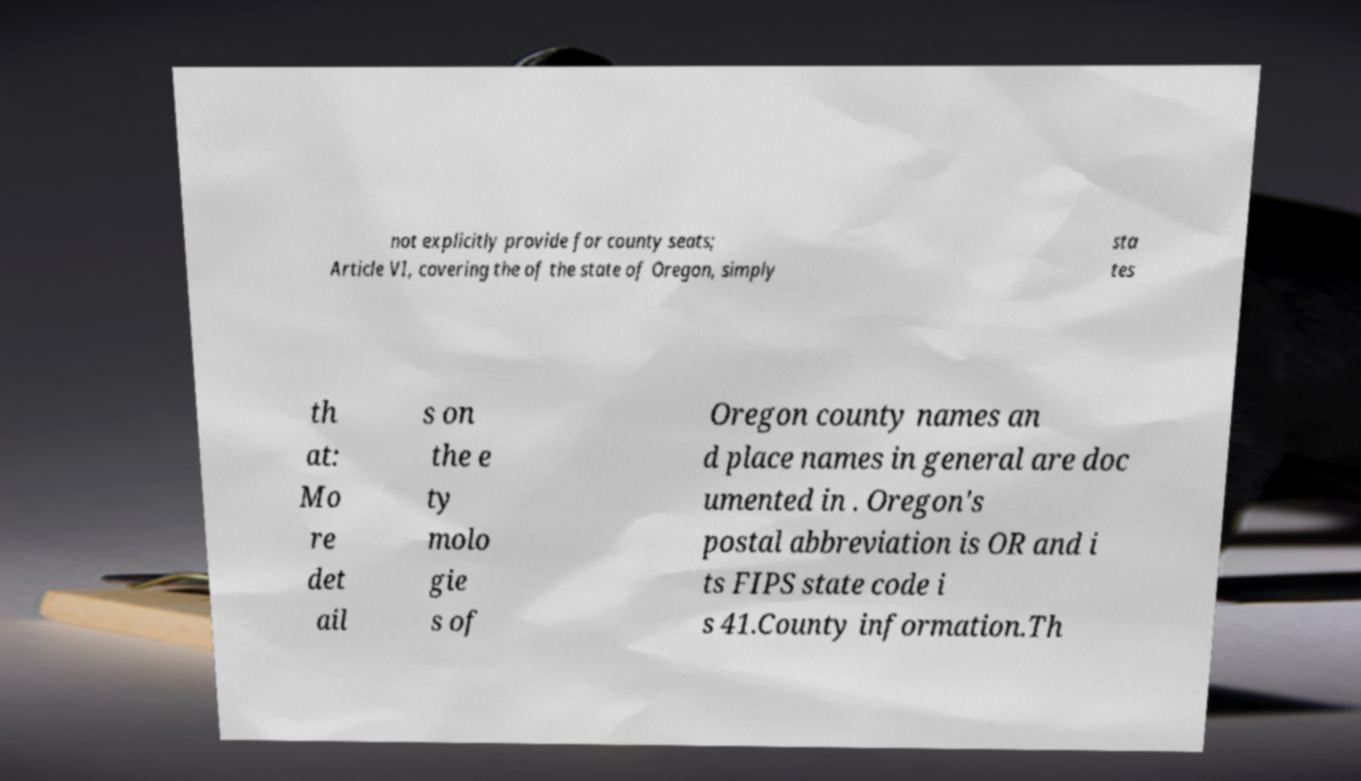Please identify and transcribe the text found in this image. not explicitly provide for county seats; Article VI, covering the of the state of Oregon, simply sta tes th at: Mo re det ail s on the e ty molo gie s of Oregon county names an d place names in general are doc umented in . Oregon's postal abbreviation is OR and i ts FIPS state code i s 41.County information.Th 